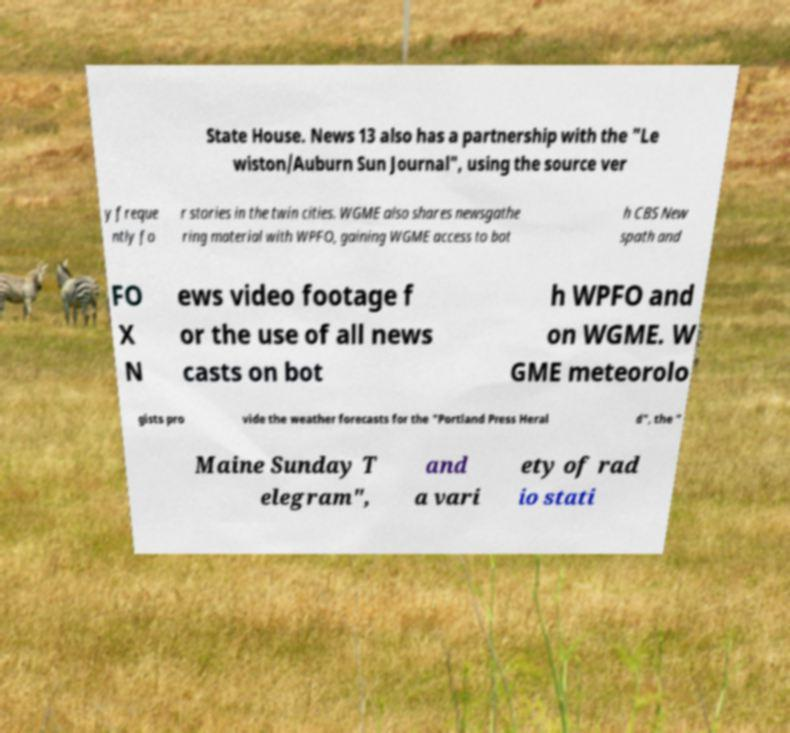Please read and relay the text visible in this image. What does it say? State House. News 13 also has a partnership with the "Le wiston/Auburn Sun Journal", using the source ver y freque ntly fo r stories in the twin cities. WGME also shares newsgathe ring material with WPFO, gaining WGME access to bot h CBS New spath and FO X N ews video footage f or the use of all news casts on bot h WPFO and on WGME. W GME meteorolo gists pro vide the weather forecasts for the "Portland Press Heral d", the " Maine Sunday T elegram", and a vari ety of rad io stati 